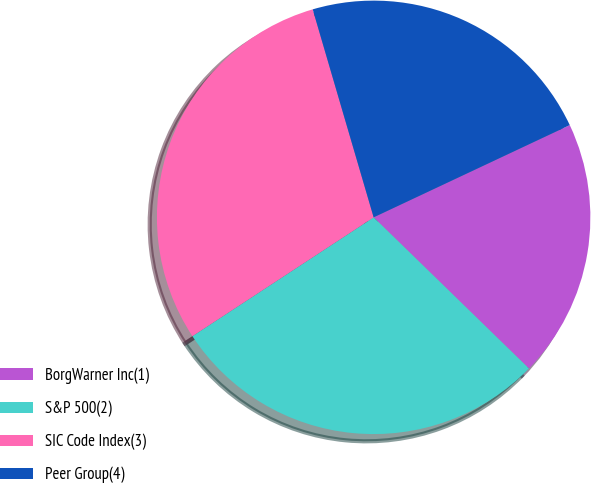Convert chart. <chart><loc_0><loc_0><loc_500><loc_500><pie_chart><fcel>BorgWarner Inc(1)<fcel>S&P 500(2)<fcel>SIC Code Index(3)<fcel>Peer Group(4)<nl><fcel>19.28%<fcel>28.48%<fcel>29.7%<fcel>22.54%<nl></chart> 